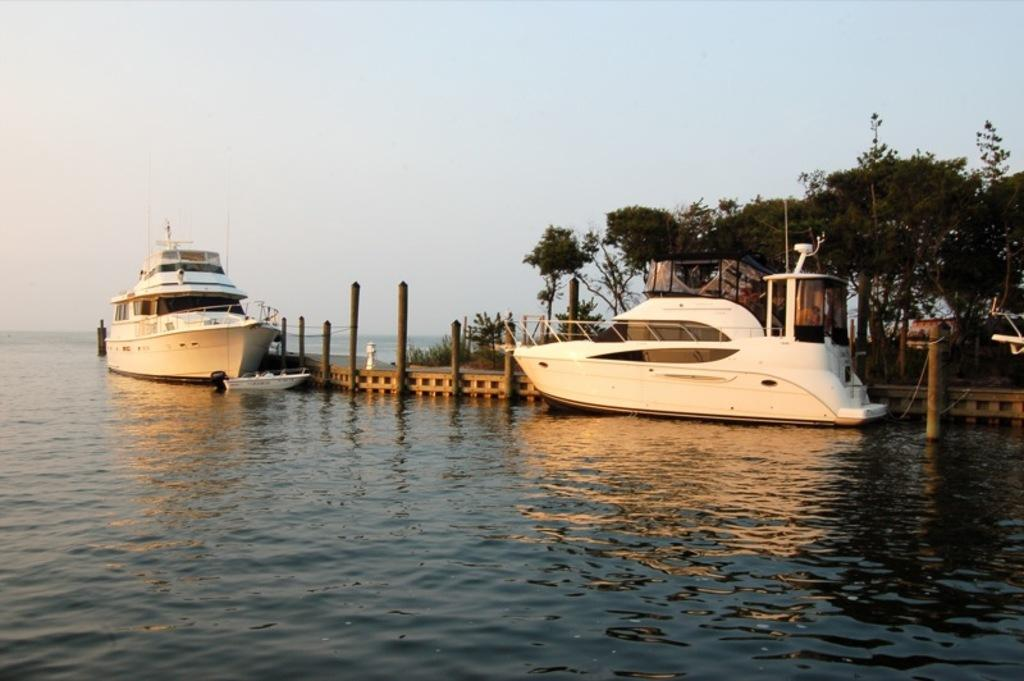What type of vehicle is in the image? There is a ship in the image. Are there any other vehicles in the image? Yes, there are boats in the image. Where are the ship and boats located? The ship and boats are on water in the image. What structures or objects can be seen beside the water? There are poles, a platform, trees, and some objects beside the water in the image. What can be seen in the background of the image? The sky is visible in the background of the image. What sign is the writer holding up in the image? There is no writer or sign present in the image. How many arms are visible in the image? There are no arms visible in the image. 